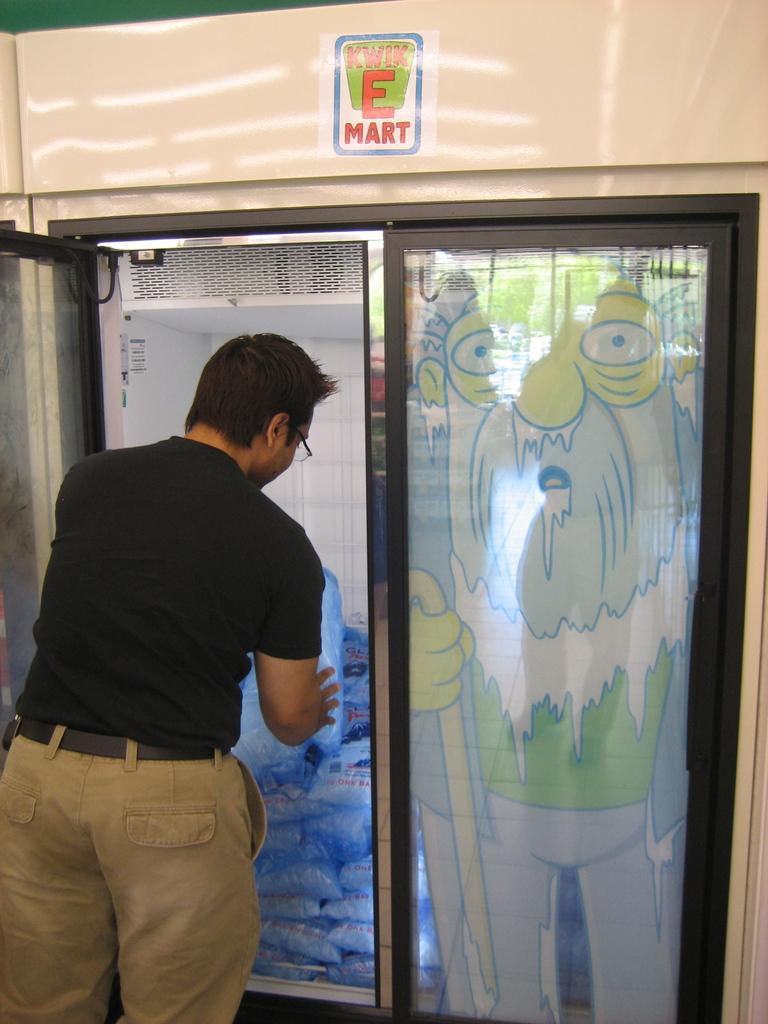<image>
Create a compact narrative representing the image presented. A man taking something from a store chiller which has Kwik E Mart written on it. 